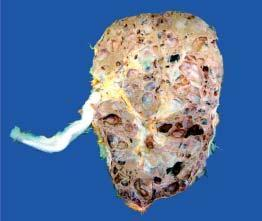what are these cysts not communicating with?
Answer the question using a single word or phrase. Pelvicalyceal system 